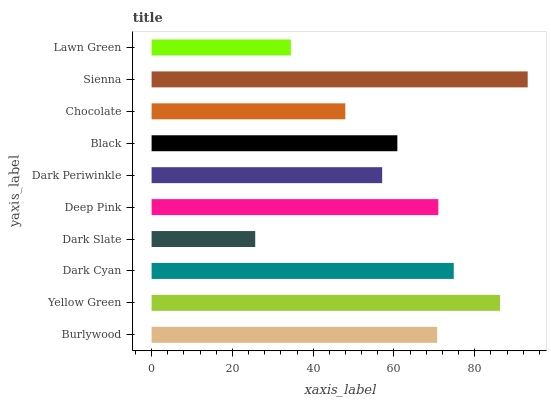Is Dark Slate the minimum?
Answer yes or no. Yes. Is Sienna the maximum?
Answer yes or no. Yes. Is Yellow Green the minimum?
Answer yes or no. No. Is Yellow Green the maximum?
Answer yes or no. No. Is Yellow Green greater than Burlywood?
Answer yes or no. Yes. Is Burlywood less than Yellow Green?
Answer yes or no. Yes. Is Burlywood greater than Yellow Green?
Answer yes or no. No. Is Yellow Green less than Burlywood?
Answer yes or no. No. Is Burlywood the high median?
Answer yes or no. Yes. Is Black the low median?
Answer yes or no. Yes. Is Black the high median?
Answer yes or no. No. Is Lawn Green the low median?
Answer yes or no. No. 